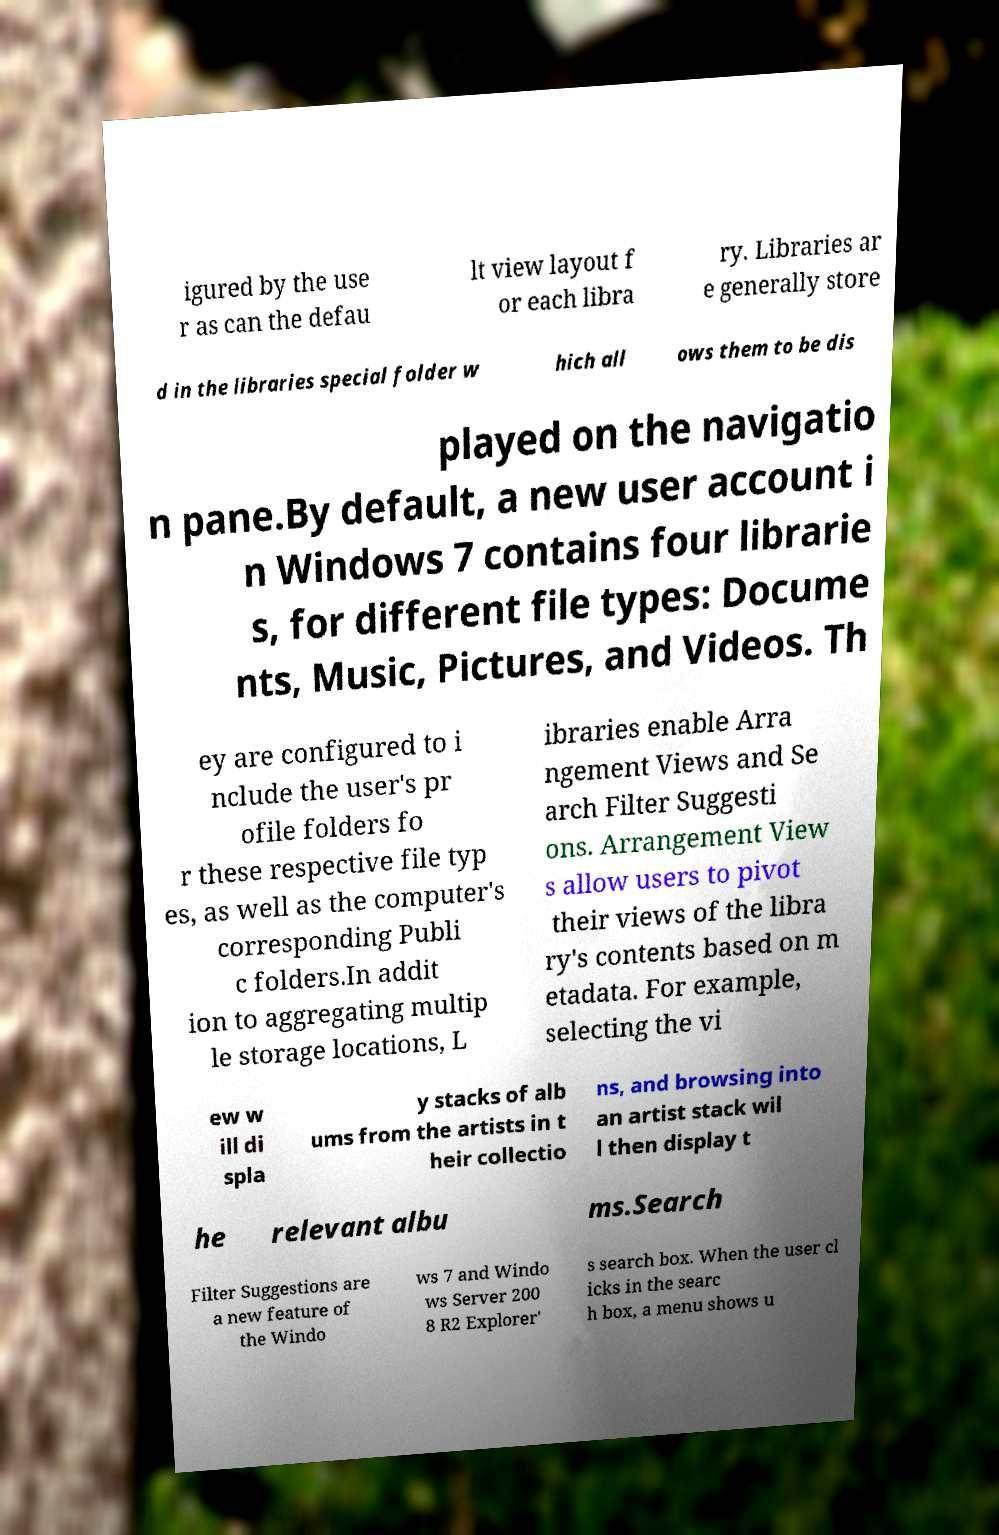There's text embedded in this image that I need extracted. Can you transcribe it verbatim? igured by the use r as can the defau lt view layout f or each libra ry. Libraries ar e generally store d in the libraries special folder w hich all ows them to be dis played on the navigatio n pane.By default, a new user account i n Windows 7 contains four librarie s, for different file types: Docume nts, Music, Pictures, and Videos. Th ey are configured to i nclude the user's pr ofile folders fo r these respective file typ es, as well as the computer's corresponding Publi c folders.In addit ion to aggregating multip le storage locations, L ibraries enable Arra ngement Views and Se arch Filter Suggesti ons. Arrangement View s allow users to pivot their views of the libra ry's contents based on m etadata. For example, selecting the vi ew w ill di spla y stacks of alb ums from the artists in t heir collectio ns, and browsing into an artist stack wil l then display t he relevant albu ms.Search Filter Suggestions are a new feature of the Windo ws 7 and Windo ws Server 200 8 R2 Explorer' s search box. When the user cl icks in the searc h box, a menu shows u 